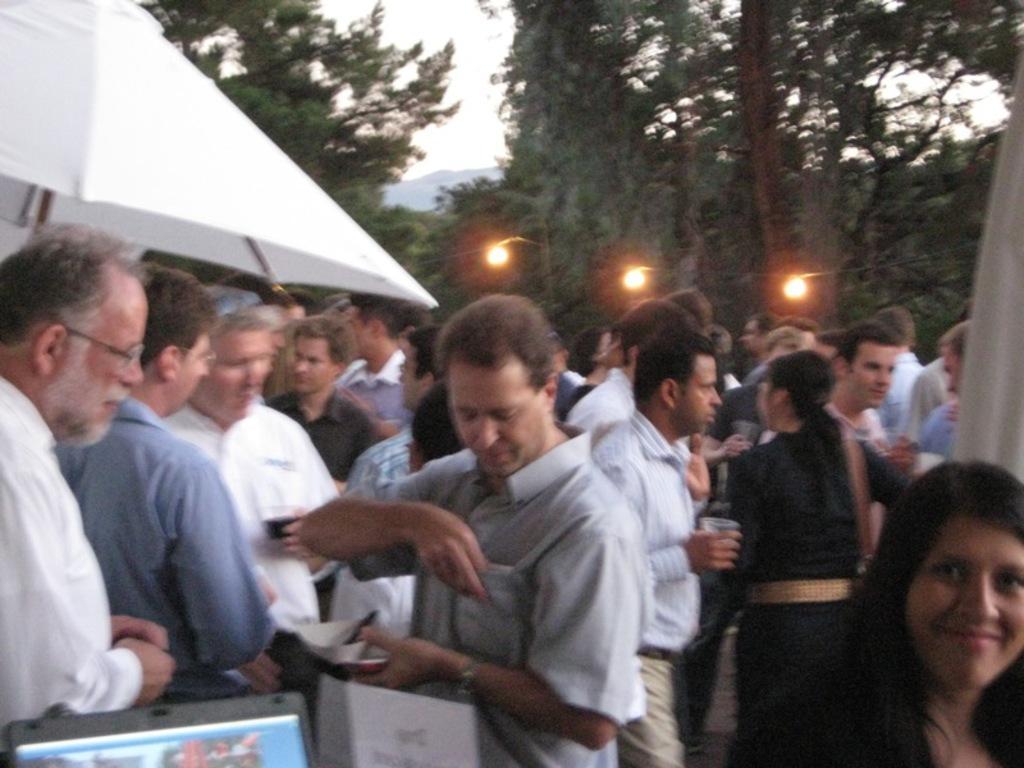How would you summarize this image in a sentence or two? In this image we can see the object looks like a mountain, some people are standing, one object with photos on the ground, some people are walking, two white color tents, one white object on the right side of the image, some people are holding some objects, three lights attached to the wire, some trees in the background and at the top there is the sky. 